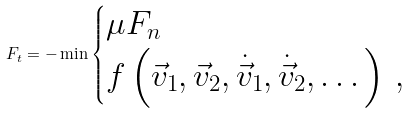Convert formula to latex. <formula><loc_0><loc_0><loc_500><loc_500>F _ { t } = - \min \begin{cases} \mu F _ { n } \\ f \left ( \vec { v } _ { 1 } , \vec { v } _ { 2 } , \dot { \vec { v } } _ { 1 } , \dot { \vec { v } } _ { 2 } , \dots \right ) \, , \end{cases}</formula> 